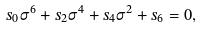Convert formula to latex. <formula><loc_0><loc_0><loc_500><loc_500>s _ { 0 } \sigma ^ { 6 } + s _ { 2 } \sigma ^ { 4 } + s _ { 4 } \sigma ^ { 2 } + s _ { 6 } = 0 ,</formula> 